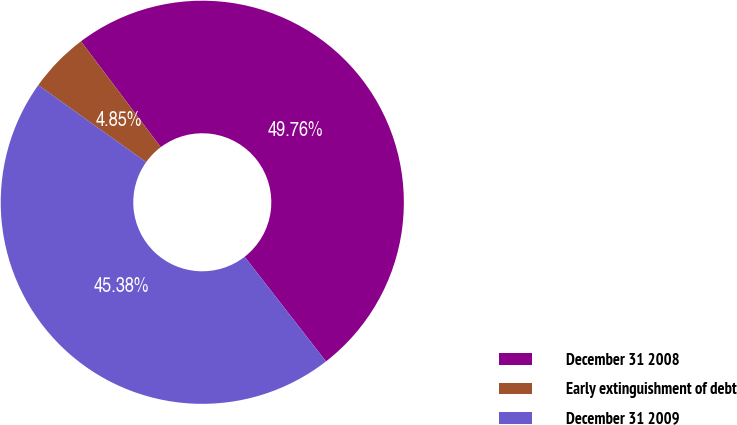Convert chart to OTSL. <chart><loc_0><loc_0><loc_500><loc_500><pie_chart><fcel>December 31 2008<fcel>Early extinguishment of debt<fcel>December 31 2009<nl><fcel>49.76%<fcel>4.85%<fcel>45.38%<nl></chart> 